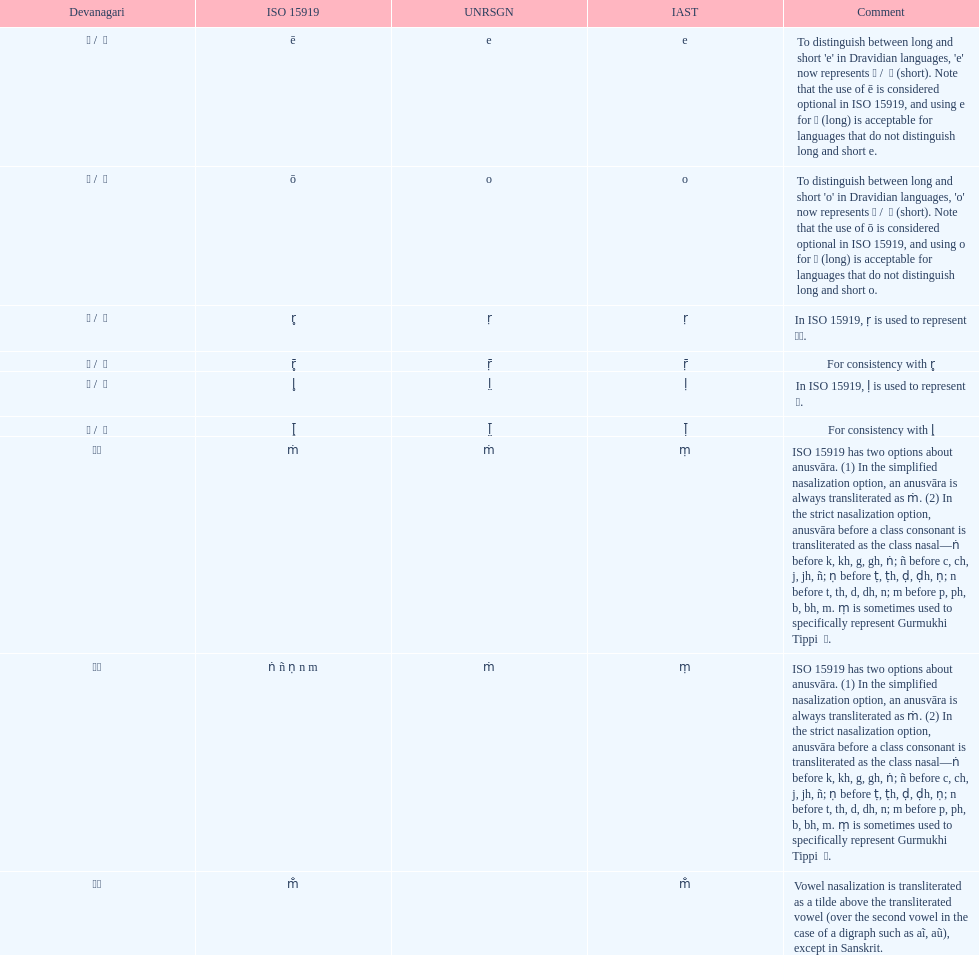Which character is mentioned before the letter 'o' in the term "unrsgn"? E. 